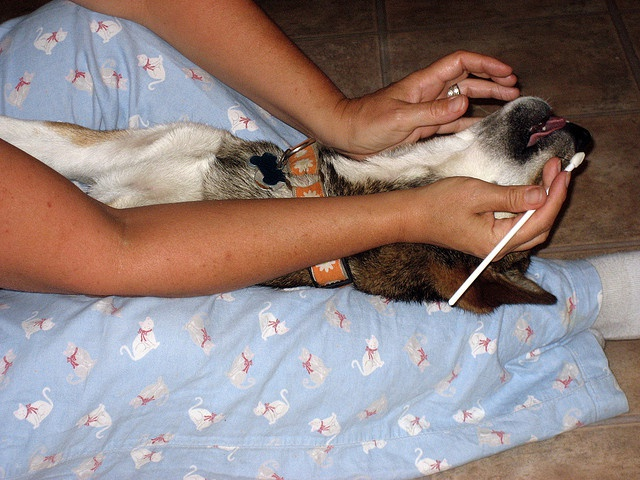Describe the objects in this image and their specific colors. I can see people in black, darkgray, lightblue, and salmon tones, dog in black, lightgray, darkgray, and maroon tones, toothbrush in black, white, and tan tones, and toothbrush in black, lightgray, tan, and darkgray tones in this image. 